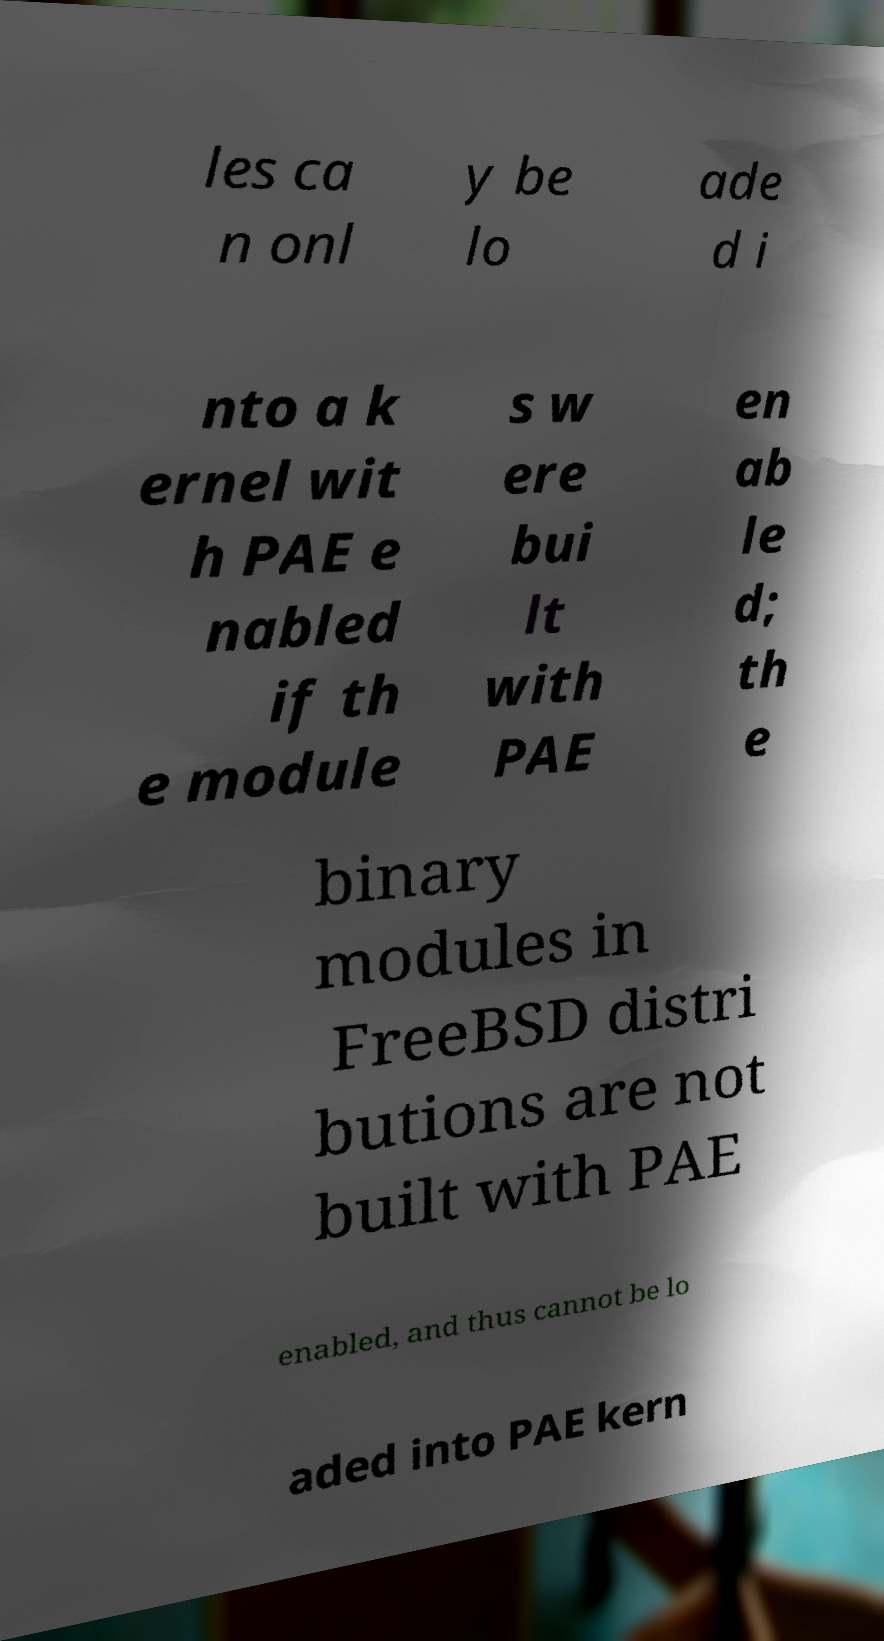Please read and relay the text visible in this image. What does it say? les ca n onl y be lo ade d i nto a k ernel wit h PAE e nabled if th e module s w ere bui lt with PAE en ab le d; th e binary modules in FreeBSD distri butions are not built with PAE enabled, and thus cannot be lo aded into PAE kern 